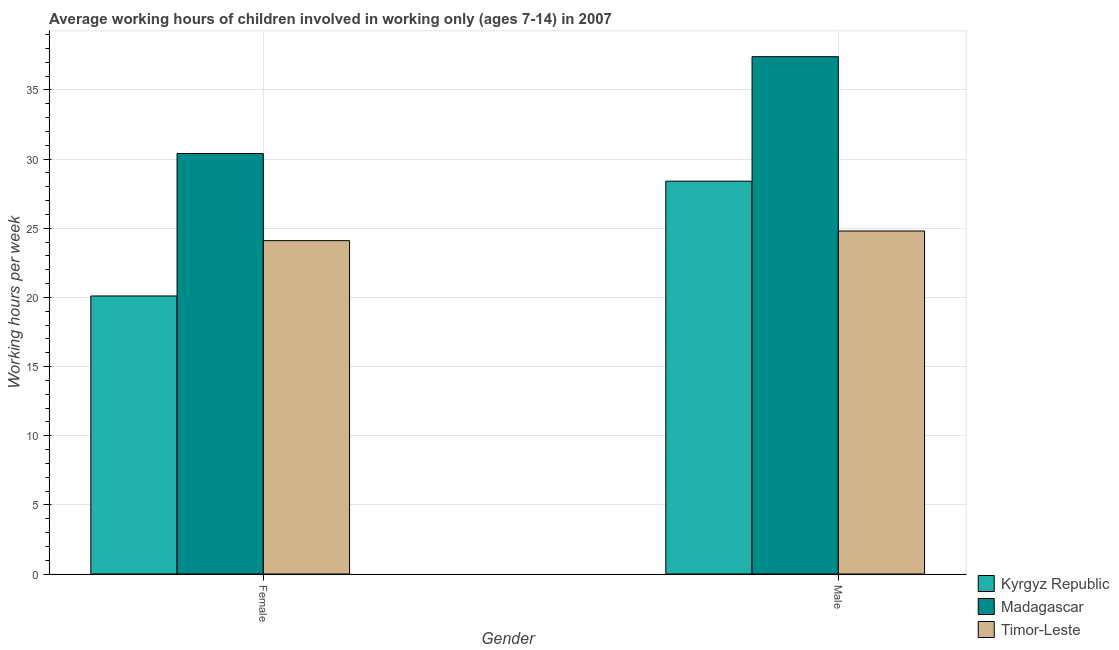How many different coloured bars are there?
Your answer should be very brief. 3. Are the number of bars on each tick of the X-axis equal?
Ensure brevity in your answer.  Yes. How many bars are there on the 2nd tick from the left?
Provide a succinct answer. 3. How many bars are there on the 1st tick from the right?
Your answer should be very brief. 3. What is the average working hour of female children in Kyrgyz Republic?
Give a very brief answer. 20.1. Across all countries, what is the maximum average working hour of male children?
Your response must be concise. 37.4. Across all countries, what is the minimum average working hour of female children?
Keep it short and to the point. 20.1. In which country was the average working hour of male children maximum?
Ensure brevity in your answer.  Madagascar. In which country was the average working hour of female children minimum?
Keep it short and to the point. Kyrgyz Republic. What is the total average working hour of male children in the graph?
Keep it short and to the point. 90.6. What is the difference between the average working hour of male children in Madagascar and that in Timor-Leste?
Make the answer very short. 12.6. What is the difference between the average working hour of male children in Madagascar and the average working hour of female children in Kyrgyz Republic?
Ensure brevity in your answer.  17.3. What is the average average working hour of male children per country?
Provide a short and direct response. 30.2. What is the difference between the average working hour of male children and average working hour of female children in Kyrgyz Republic?
Ensure brevity in your answer.  8.3. In how many countries, is the average working hour of male children greater than 20 hours?
Provide a short and direct response. 3. What is the ratio of the average working hour of male children in Timor-Leste to that in Madagascar?
Offer a very short reply. 0.66. In how many countries, is the average working hour of female children greater than the average average working hour of female children taken over all countries?
Your answer should be compact. 1. What does the 2nd bar from the left in Female represents?
Keep it short and to the point. Madagascar. What does the 3rd bar from the right in Female represents?
Offer a terse response. Kyrgyz Republic. Are all the bars in the graph horizontal?
Ensure brevity in your answer.  No. How many countries are there in the graph?
Keep it short and to the point. 3. Does the graph contain any zero values?
Give a very brief answer. No. Does the graph contain grids?
Your response must be concise. Yes. Where does the legend appear in the graph?
Your response must be concise. Bottom right. What is the title of the graph?
Provide a short and direct response. Average working hours of children involved in working only (ages 7-14) in 2007. Does "Greece" appear as one of the legend labels in the graph?
Keep it short and to the point. No. What is the label or title of the Y-axis?
Make the answer very short. Working hours per week. What is the Working hours per week of Kyrgyz Republic in Female?
Give a very brief answer. 20.1. What is the Working hours per week of Madagascar in Female?
Ensure brevity in your answer.  30.4. What is the Working hours per week in Timor-Leste in Female?
Your answer should be very brief. 24.1. What is the Working hours per week of Kyrgyz Republic in Male?
Your answer should be compact. 28.4. What is the Working hours per week of Madagascar in Male?
Your answer should be compact. 37.4. What is the Working hours per week in Timor-Leste in Male?
Provide a short and direct response. 24.8. Across all Gender, what is the maximum Working hours per week of Kyrgyz Republic?
Provide a short and direct response. 28.4. Across all Gender, what is the maximum Working hours per week of Madagascar?
Your answer should be very brief. 37.4. Across all Gender, what is the maximum Working hours per week of Timor-Leste?
Your answer should be compact. 24.8. Across all Gender, what is the minimum Working hours per week of Kyrgyz Republic?
Your answer should be compact. 20.1. Across all Gender, what is the minimum Working hours per week of Madagascar?
Offer a very short reply. 30.4. Across all Gender, what is the minimum Working hours per week in Timor-Leste?
Give a very brief answer. 24.1. What is the total Working hours per week in Kyrgyz Republic in the graph?
Your answer should be compact. 48.5. What is the total Working hours per week of Madagascar in the graph?
Offer a very short reply. 67.8. What is the total Working hours per week in Timor-Leste in the graph?
Your answer should be very brief. 48.9. What is the difference between the Working hours per week of Timor-Leste in Female and that in Male?
Give a very brief answer. -0.7. What is the difference between the Working hours per week of Kyrgyz Republic in Female and the Working hours per week of Madagascar in Male?
Offer a terse response. -17.3. What is the difference between the Working hours per week of Kyrgyz Republic in Female and the Working hours per week of Timor-Leste in Male?
Ensure brevity in your answer.  -4.7. What is the average Working hours per week of Kyrgyz Republic per Gender?
Make the answer very short. 24.25. What is the average Working hours per week in Madagascar per Gender?
Your response must be concise. 33.9. What is the average Working hours per week in Timor-Leste per Gender?
Provide a succinct answer. 24.45. What is the difference between the Working hours per week of Kyrgyz Republic and Working hours per week of Timor-Leste in Female?
Keep it short and to the point. -4. What is the difference between the Working hours per week in Kyrgyz Republic and Working hours per week in Madagascar in Male?
Provide a short and direct response. -9. What is the difference between the Working hours per week in Madagascar and Working hours per week in Timor-Leste in Male?
Provide a short and direct response. 12.6. What is the ratio of the Working hours per week in Kyrgyz Republic in Female to that in Male?
Keep it short and to the point. 0.71. What is the ratio of the Working hours per week of Madagascar in Female to that in Male?
Give a very brief answer. 0.81. What is the ratio of the Working hours per week in Timor-Leste in Female to that in Male?
Offer a very short reply. 0.97. What is the difference between the highest and the second highest Working hours per week in Timor-Leste?
Offer a terse response. 0.7. What is the difference between the highest and the lowest Working hours per week in Madagascar?
Offer a terse response. 7. What is the difference between the highest and the lowest Working hours per week in Timor-Leste?
Your response must be concise. 0.7. 